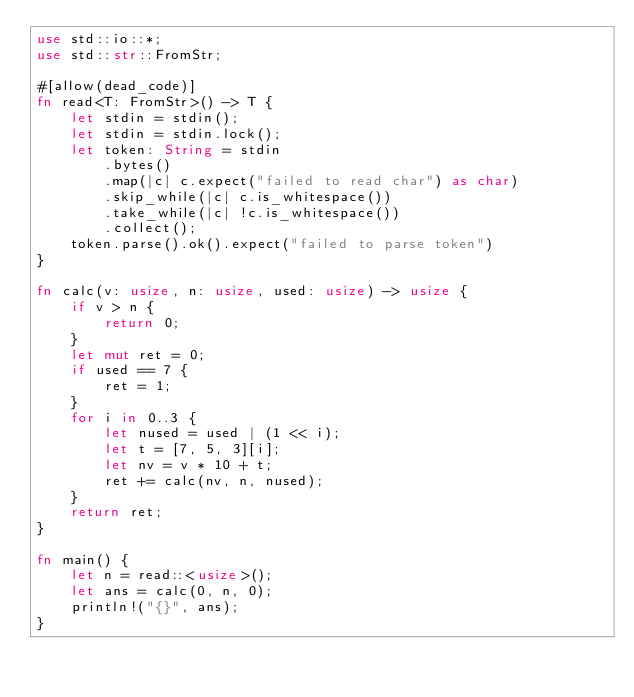<code> <loc_0><loc_0><loc_500><loc_500><_Rust_>use std::io::*;
use std::str::FromStr;

#[allow(dead_code)]
fn read<T: FromStr>() -> T {
    let stdin = stdin();
    let stdin = stdin.lock();
    let token: String = stdin
        .bytes()
        .map(|c| c.expect("failed to read char") as char)
        .skip_while(|c| c.is_whitespace())
        .take_while(|c| !c.is_whitespace())
        .collect();
    token.parse().ok().expect("failed to parse token")
}

fn calc(v: usize, n: usize, used: usize) -> usize {
    if v > n {
        return 0;
    }
    let mut ret = 0;
    if used == 7 {
        ret = 1;
    }
    for i in 0..3 {
        let nused = used | (1 << i);
        let t = [7, 5, 3][i];
        let nv = v * 10 + t;
        ret += calc(nv, n, nused);
    }
    return ret;
}

fn main() {
    let n = read::<usize>();
    let ans = calc(0, n, 0);
    println!("{}", ans);
}
</code> 